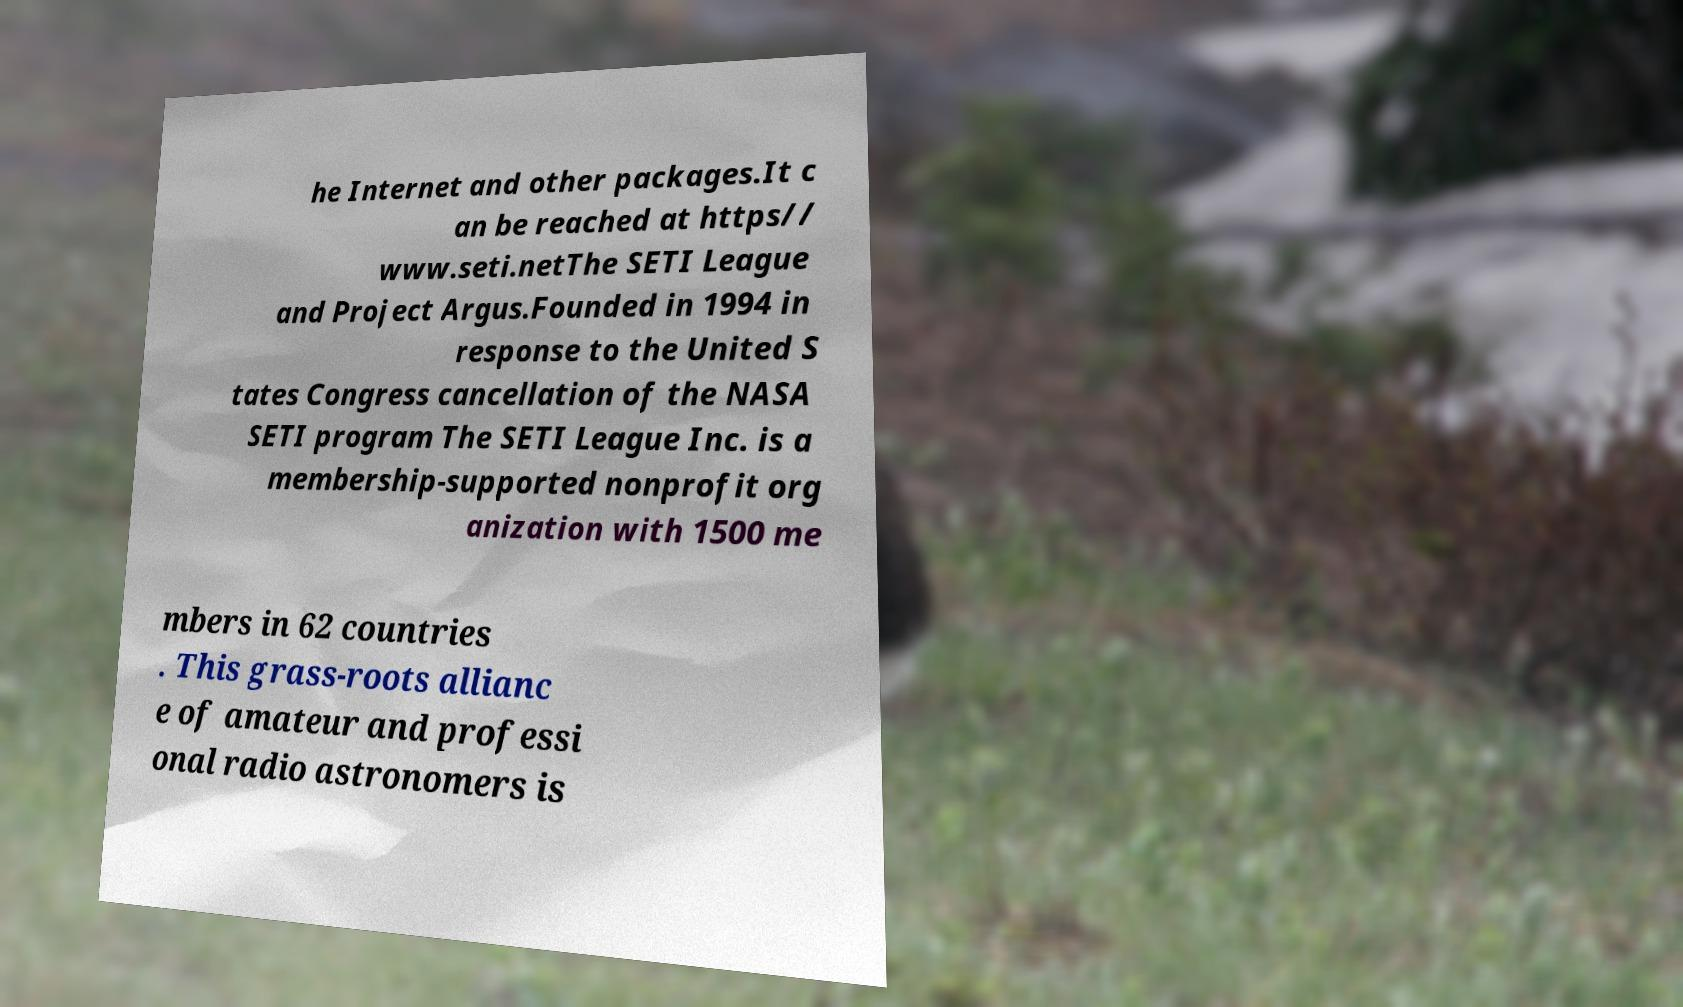Can you accurately transcribe the text from the provided image for me? he Internet and other packages.It c an be reached at https// www.seti.netThe SETI League and Project Argus.Founded in 1994 in response to the United S tates Congress cancellation of the NASA SETI program The SETI League Inc. is a membership-supported nonprofit org anization with 1500 me mbers in 62 countries . This grass-roots allianc e of amateur and professi onal radio astronomers is 